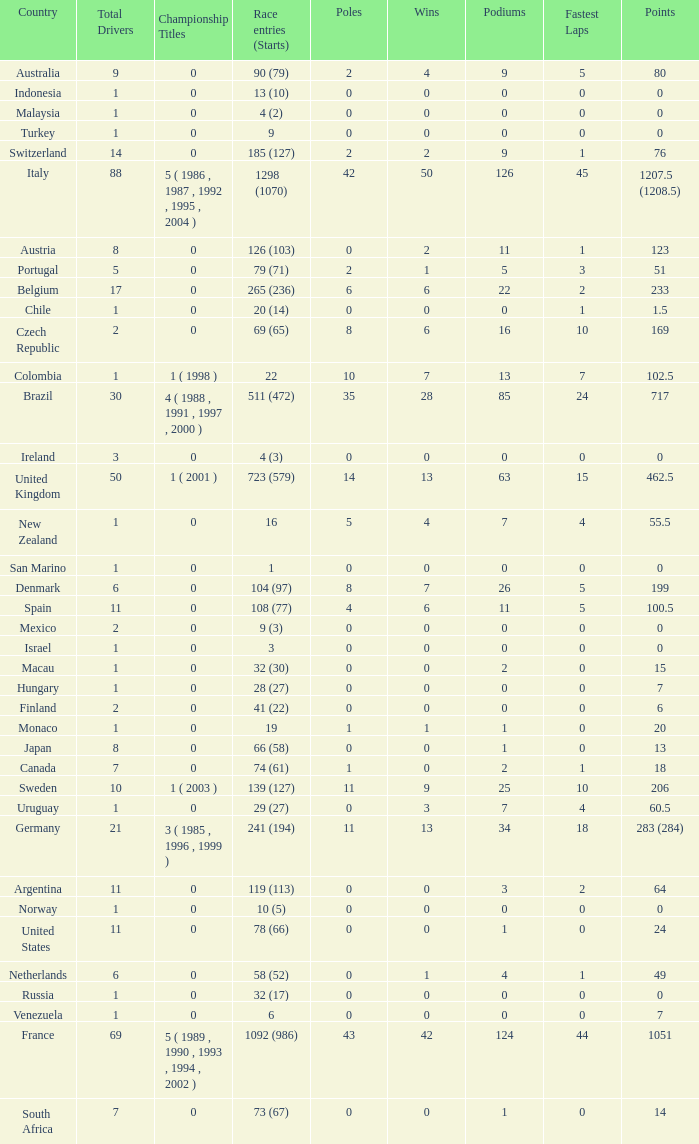How many fastest laps for the nation with 32 (30) entries and starts and fewer than 2 podiums? None. 